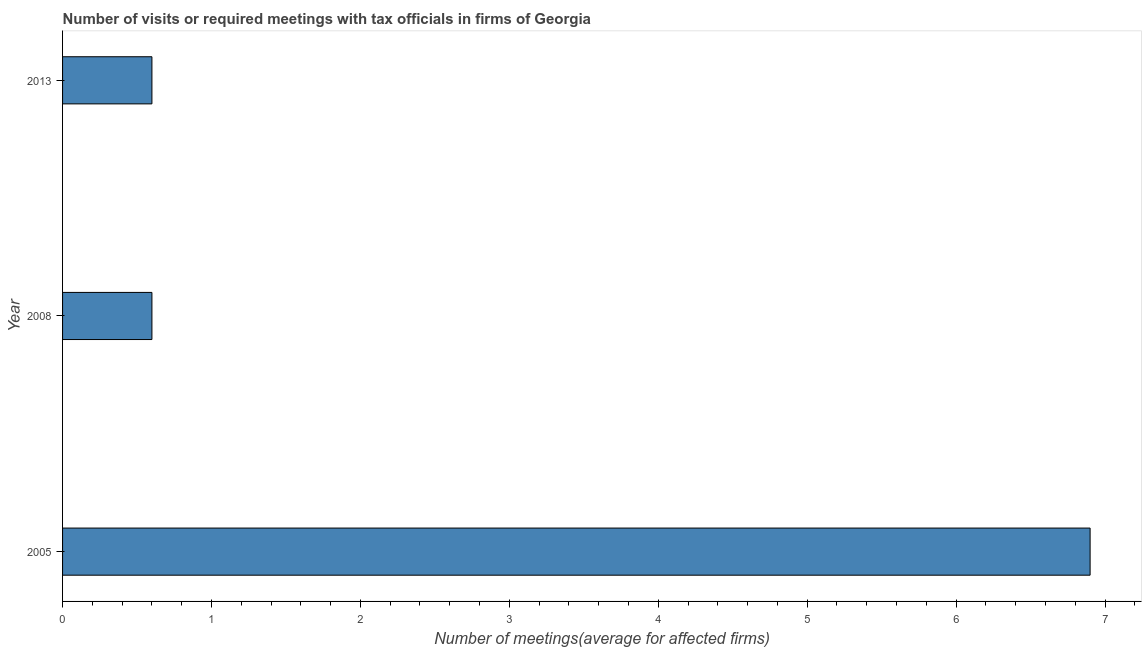What is the title of the graph?
Provide a succinct answer. Number of visits or required meetings with tax officials in firms of Georgia. What is the label or title of the X-axis?
Make the answer very short. Number of meetings(average for affected firms). What is the number of required meetings with tax officials in 2013?
Provide a succinct answer. 0.6. Across all years, what is the maximum number of required meetings with tax officials?
Offer a very short reply. 6.9. In which year was the number of required meetings with tax officials maximum?
Provide a succinct answer. 2005. What is the sum of the number of required meetings with tax officials?
Give a very brief answer. 8.1. What is the difference between the number of required meetings with tax officials in 2005 and 2008?
Your response must be concise. 6.3. In how many years, is the number of required meetings with tax officials greater than 3.8 ?
Provide a short and direct response. 1. Do a majority of the years between 2008 and 2013 (inclusive) have number of required meetings with tax officials greater than 6.6 ?
Provide a short and direct response. No. What is the ratio of the number of required meetings with tax officials in 2008 to that in 2013?
Your response must be concise. 1. Is the number of required meetings with tax officials in 2008 less than that in 2013?
Your answer should be very brief. No. Is the difference between the number of required meetings with tax officials in 2008 and 2013 greater than the difference between any two years?
Your answer should be compact. No. What is the difference between the highest and the second highest number of required meetings with tax officials?
Your response must be concise. 6.3. Is the sum of the number of required meetings with tax officials in 2005 and 2008 greater than the maximum number of required meetings with tax officials across all years?
Your response must be concise. Yes. What is the difference between the highest and the lowest number of required meetings with tax officials?
Your response must be concise. 6.3. How many bars are there?
Provide a succinct answer. 3. What is the difference between two consecutive major ticks on the X-axis?
Provide a succinct answer. 1. Are the values on the major ticks of X-axis written in scientific E-notation?
Make the answer very short. No. What is the Number of meetings(average for affected firms) in 2008?
Your answer should be very brief. 0.6. What is the difference between the Number of meetings(average for affected firms) in 2008 and 2013?
Make the answer very short. 0. What is the ratio of the Number of meetings(average for affected firms) in 2005 to that in 2013?
Your response must be concise. 11.5. What is the ratio of the Number of meetings(average for affected firms) in 2008 to that in 2013?
Provide a succinct answer. 1. 